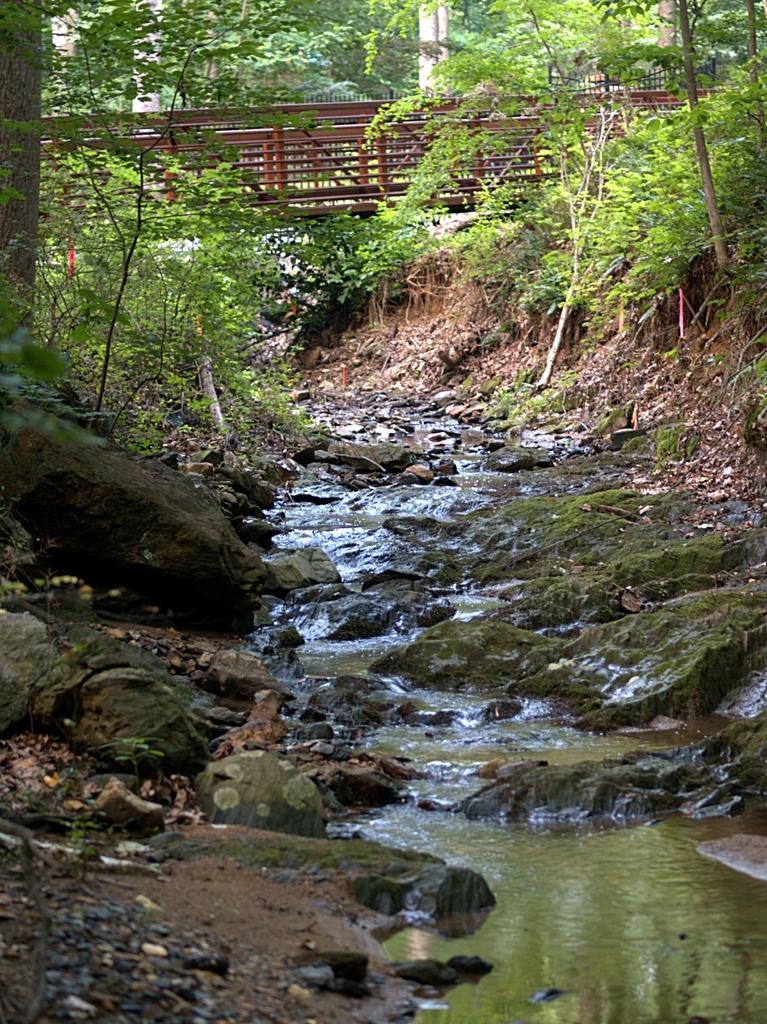In one or two sentences, can you explain what this image depicts? In this image we can see a group of trees, stones and the water. We can also see the bark of the trees and a bridge. 